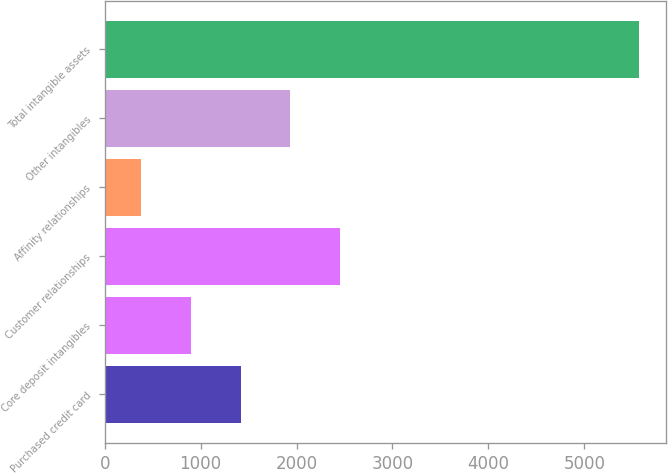<chart> <loc_0><loc_0><loc_500><loc_500><bar_chart><fcel>Purchased credit card<fcel>Core deposit intangibles<fcel>Customer relationships<fcel>Affinity relationships<fcel>Other intangibles<fcel>Total intangible assets<nl><fcel>1417.2<fcel>897.6<fcel>2456.4<fcel>378<fcel>1936.8<fcel>5574<nl></chart> 